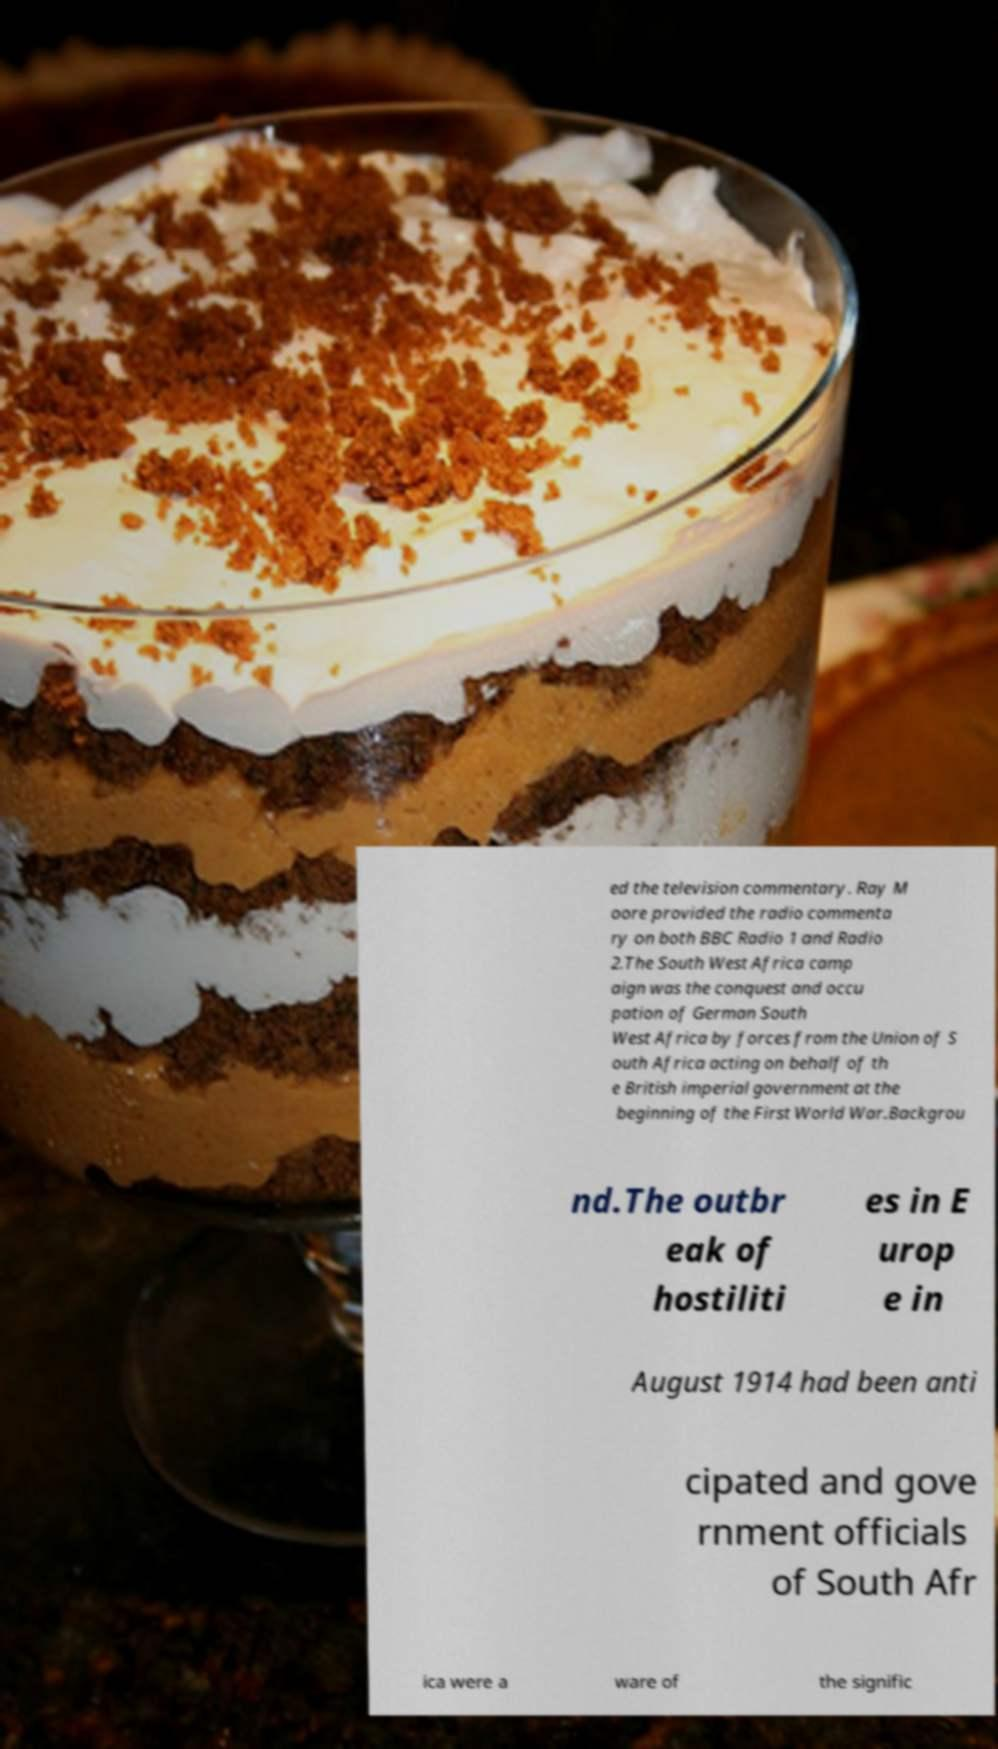Please identify and transcribe the text found in this image. ed the television commentary. Ray M oore provided the radio commenta ry on both BBC Radio 1 and Radio 2.The South West Africa camp aign was the conquest and occu pation of German South West Africa by forces from the Union of S outh Africa acting on behalf of th e British imperial government at the beginning of the First World War.Backgrou nd.The outbr eak of hostiliti es in E urop e in August 1914 had been anti cipated and gove rnment officials of South Afr ica were a ware of the signific 